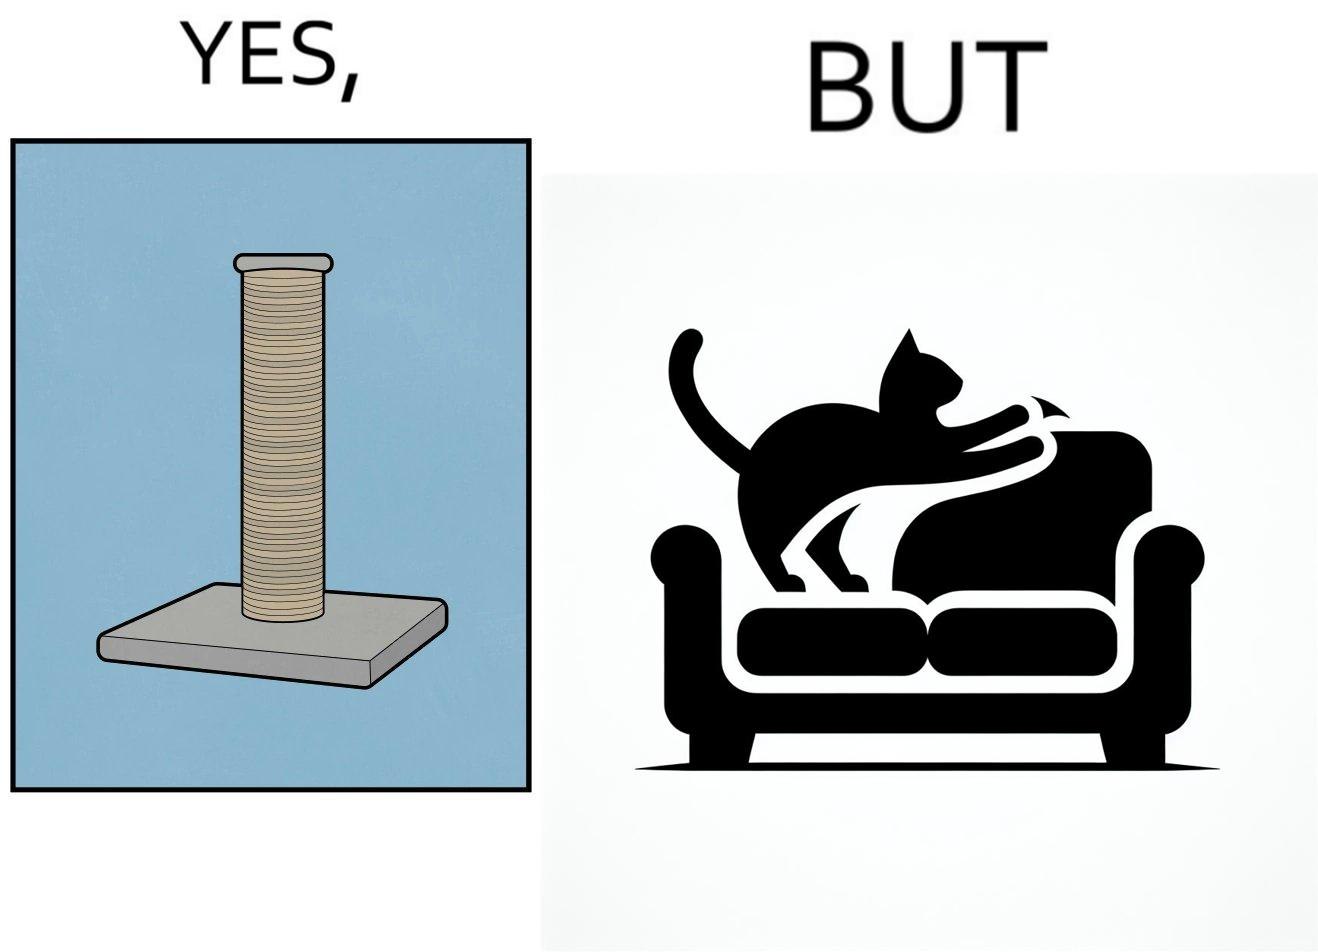What do you see in each half of this image? In the left part of the image: a cylindrical toy or some sort of thing  with a lots of rope wounded around its surface In the right part of the image: a cat scratching its nails over the sides of a sofa or trying to climb up the sofa 